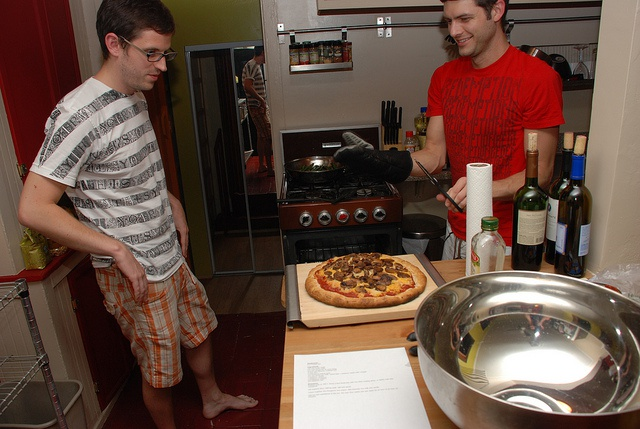Describe the objects in this image and their specific colors. I can see people in maroon, gray, and darkgray tones, bowl in maroon, gray, white, darkgray, and black tones, people in maroon, black, and brown tones, dining table in maroon, lightgray, tan, and brown tones, and oven in maroon, black, and gray tones in this image. 